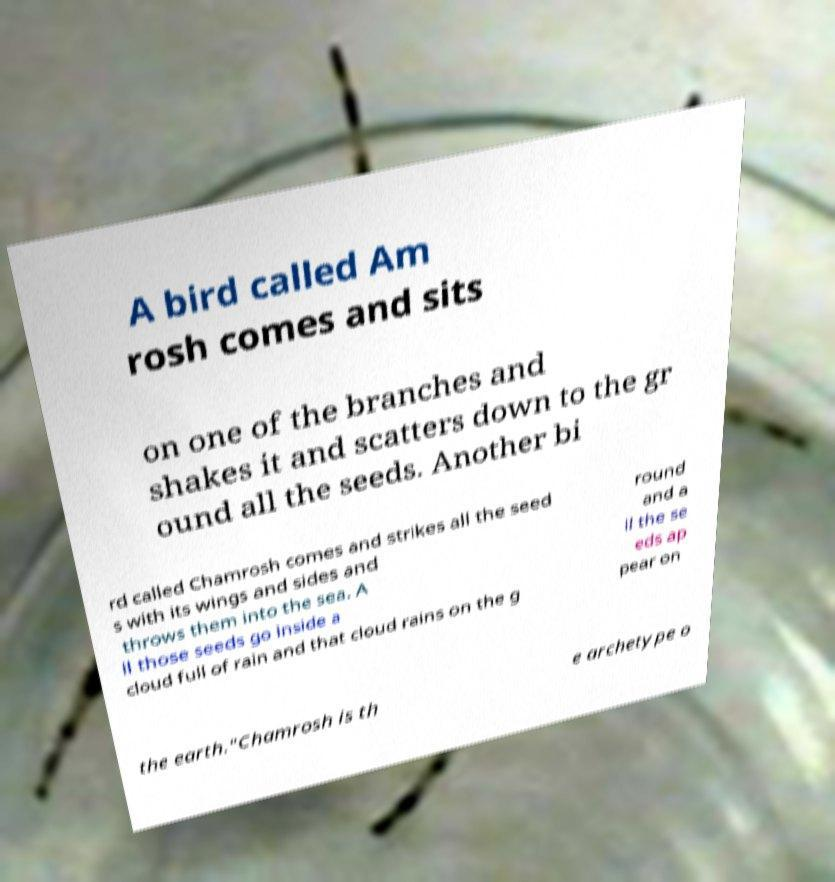Can you accurately transcribe the text from the provided image for me? A bird called Am rosh comes and sits on one of the branches and shakes it and scatters down to the gr ound all the seeds. Another bi rd called Chamrosh comes and strikes all the seed s with its wings and sides and throws them into the sea. A ll those seeds go inside a cloud full of rain and that cloud rains on the g round and a ll the se eds ap pear on the earth."Chamrosh is th e archetype o 